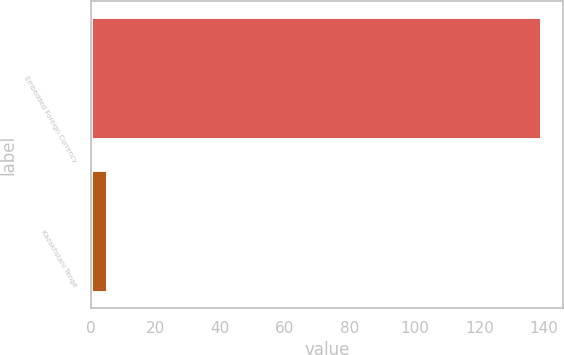Convert chart to OTSL. <chart><loc_0><loc_0><loc_500><loc_500><bar_chart><fcel>Embedded Foreign Currency<fcel>Kazakhstani Tenge<nl><fcel>139<fcel>5<nl></chart> 